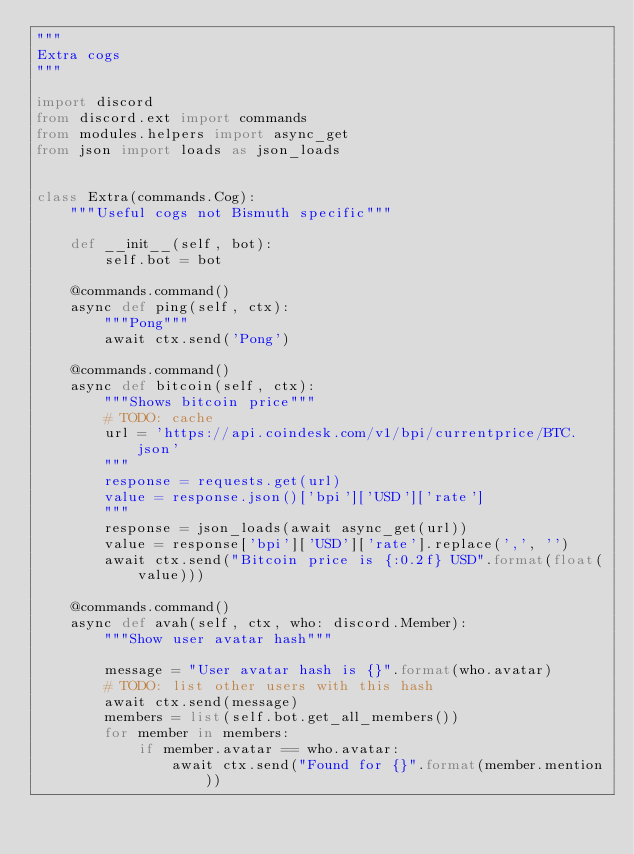Convert code to text. <code><loc_0><loc_0><loc_500><loc_500><_Python_>"""
Extra cogs
"""

import discord
from discord.ext import commands
from modules.helpers import async_get
from json import loads as json_loads


class Extra(commands.Cog):
    """Useful cogs not Bismuth specific"""

    def __init__(self, bot):
        self.bot = bot

    @commands.command()
    async def ping(self, ctx):
        """Pong"""
        await ctx.send('Pong')

    @commands.command()
    async def bitcoin(self, ctx):
        """Shows bitcoin price"""
        # TODO: cache
        url = 'https://api.coindesk.com/v1/bpi/currentprice/BTC.json'
        """
        response = requests.get(url)
        value = response.json()['bpi']['USD']['rate']
        """
        response = json_loads(await async_get(url))
        value = response['bpi']['USD']['rate'].replace(',', '')
        await ctx.send("Bitcoin price is {:0.2f} USD".format(float(value)))

    @commands.command()
    async def avah(self, ctx, who: discord.Member):
        """Show user avatar hash"""

        message = "User avatar hash is {}".format(who.avatar)
        # TODO: list other users with this hash
        await ctx.send(message)
        members = list(self.bot.get_all_members()) 
        for member in members:
            if member.avatar == who.avatar:
                await ctx.send("Found for {}".format(member.mention))
</code> 